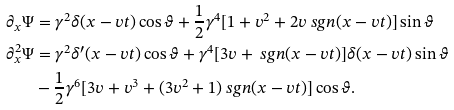Convert formula to latex. <formula><loc_0><loc_0><loc_500><loc_500>\partial _ { x } \Psi & = \gamma ^ { 2 } \delta ( x - v t ) \cos \vartheta + { \frac { 1 } { 2 } } \gamma ^ { 4 } [ 1 + v ^ { 2 } + 2 v \ s g n ( x - v t ) ] \sin \vartheta \\ \partial _ { x } ^ { 2 } \Psi & = \gamma ^ { 2 } \delta ^ { \prime } ( x - v t ) \cos \vartheta + \gamma ^ { 4 } [ 3 v + \ s g n ( x - v t ) ] \delta ( x - v t ) \sin \vartheta \\ & - { \frac { 1 } { 2 } } \gamma ^ { 6 } [ 3 v + v ^ { 3 } + ( 3 v ^ { 2 } + 1 ) \ s g n ( x - v t ) ] \cos \vartheta .</formula> 